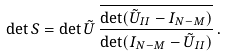<formula> <loc_0><loc_0><loc_500><loc_500>\det S = \det \tilde { U } \, \frac { \overline { \det ( \tilde { U } _ { I I } - I _ { N - M } ) } } { \det ( I _ { N - M } - \tilde { U } _ { I I } ) } \, .</formula> 